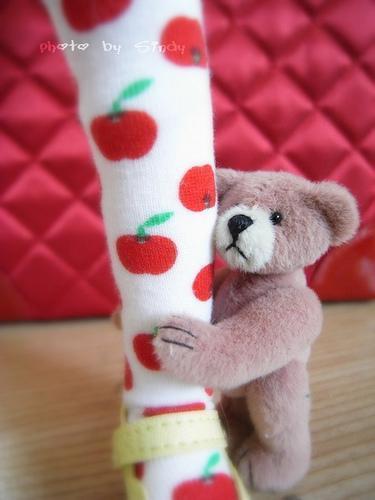How many of the teddy bears eyes are shown in the photo?
Give a very brief answer. 1. 